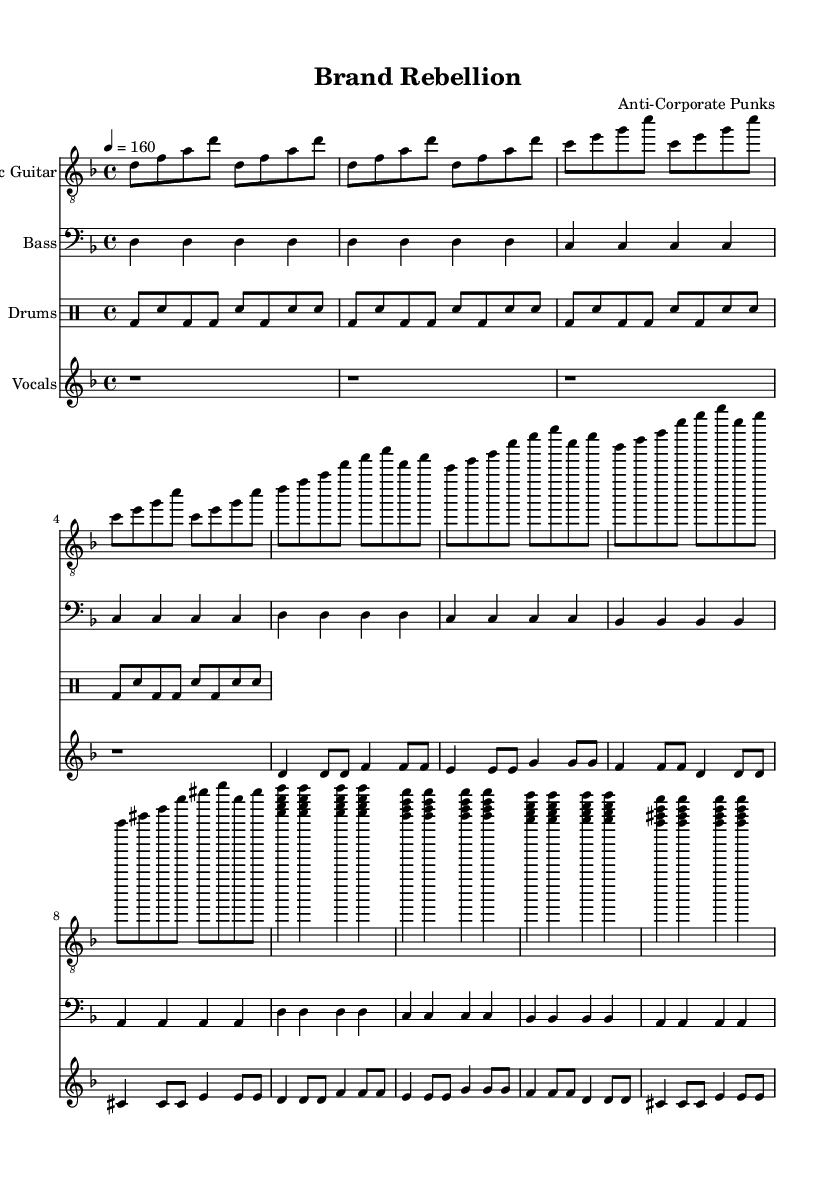What is the key signature of this music? The key signature is D minor, which has one flat (B flat). This can be determined by looking at the key signature at the beginning of the staff, revealing that it corresponds to D minor.
Answer: D minor What is the time signature of the piece? The time signature indicated at the beginning of the score is 4/4. This means there are four beats in each measure and the quarter note gets one beat. It is evident from the notation written next to the key signature.
Answer: 4/4 What is the tempo indicated for the music? The tempo is marked as 160 beats per minute, indicated by the marking "4 = 160" which specifies the speed at which the piece should be played, providing a clear instruction for performance.
Answer: 160 How many measures are there in the verse section of the music? There are eight measures in the verse section as indicated by the repeated patterns and structure of the music, counting the measures from the introduction to the end of the verse.
Answer: Eight What distinguishes the chorus from the verse in terms of structure? The chorus is characterized by a consistent pattern of four chords played in a sequence, providing a contrast to the verse which has varied rhythms and pitches. This repetitive and unified chord progression is a typical feature of punk rock music.
Answer: Repetitive chord progression What type of drum pattern is used in this piece? The drum pattern is a basic punk beat consisting of alternating bass and snare drum hits. This is common in punk rock to create a driving rhythm, evident in the rhythmic layout of the drum part in the score.
Answer: Basic punk beat What is the primary theme conveyed through the lyrics in the song? The lyrics reflect themes of resistance against manipulative branding and social control, which aligns with the anti-corporate sentiment common in punk rock protest songs. This can be deduced from the phrases and context of the lyrics provided.
Answer: Anti-corporate sentiment 